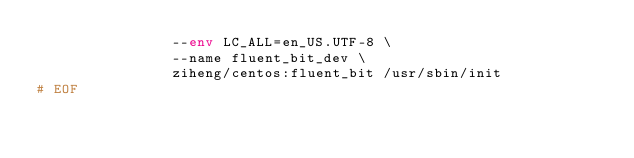<code> <loc_0><loc_0><loc_500><loc_500><_Bash_>                --env LC_ALL=en_US.UTF-8 \
                --name fluent_bit_dev \
                ziheng/centos:fluent_bit /usr/sbin/init
# EOF
</code> 